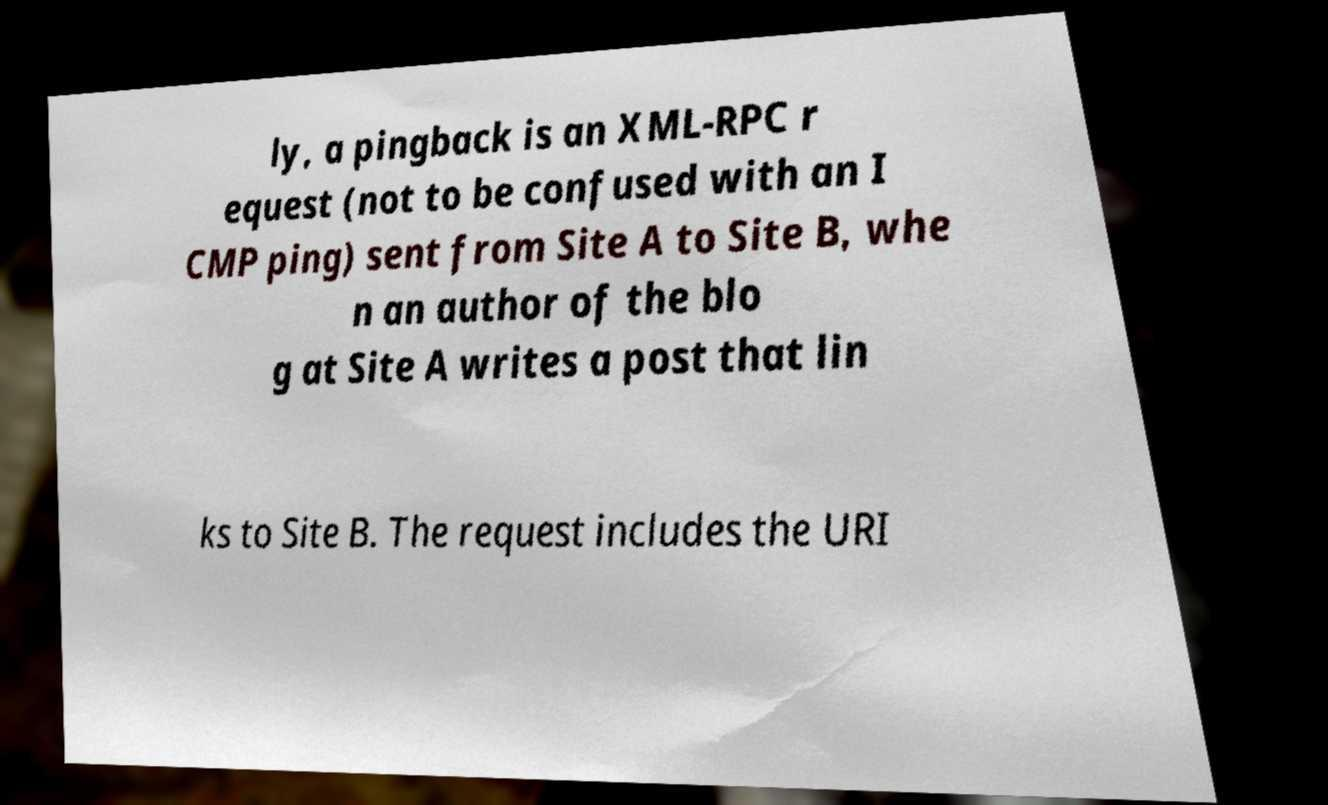I need the written content from this picture converted into text. Can you do that? ly, a pingback is an XML-RPC r equest (not to be confused with an I CMP ping) sent from Site A to Site B, whe n an author of the blo g at Site A writes a post that lin ks to Site B. The request includes the URI 